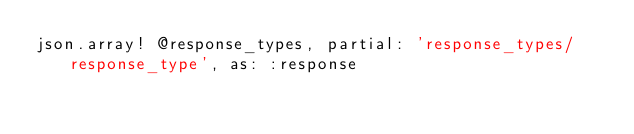<code> <loc_0><loc_0><loc_500><loc_500><_Ruby_>json.array! @response_types, partial: 'response_types/response_type', as: :response
</code> 